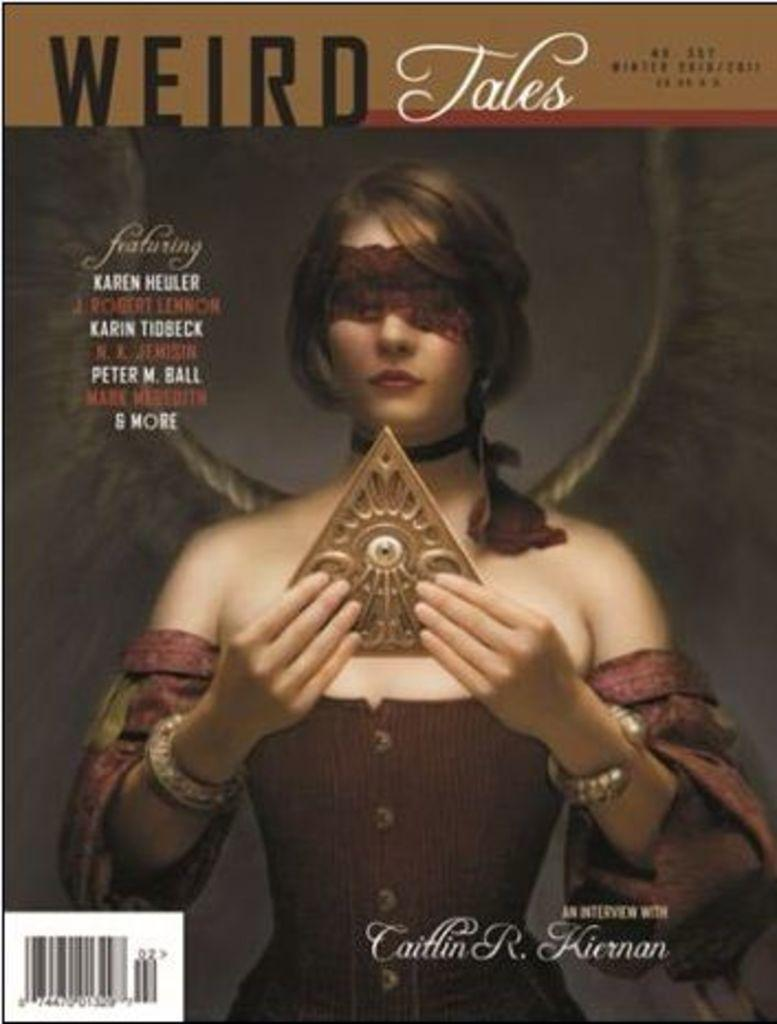<image>
Offer a succinct explanation of the picture presented. A cover has the title Weird Tales and shows a woman holding a triangular object. 